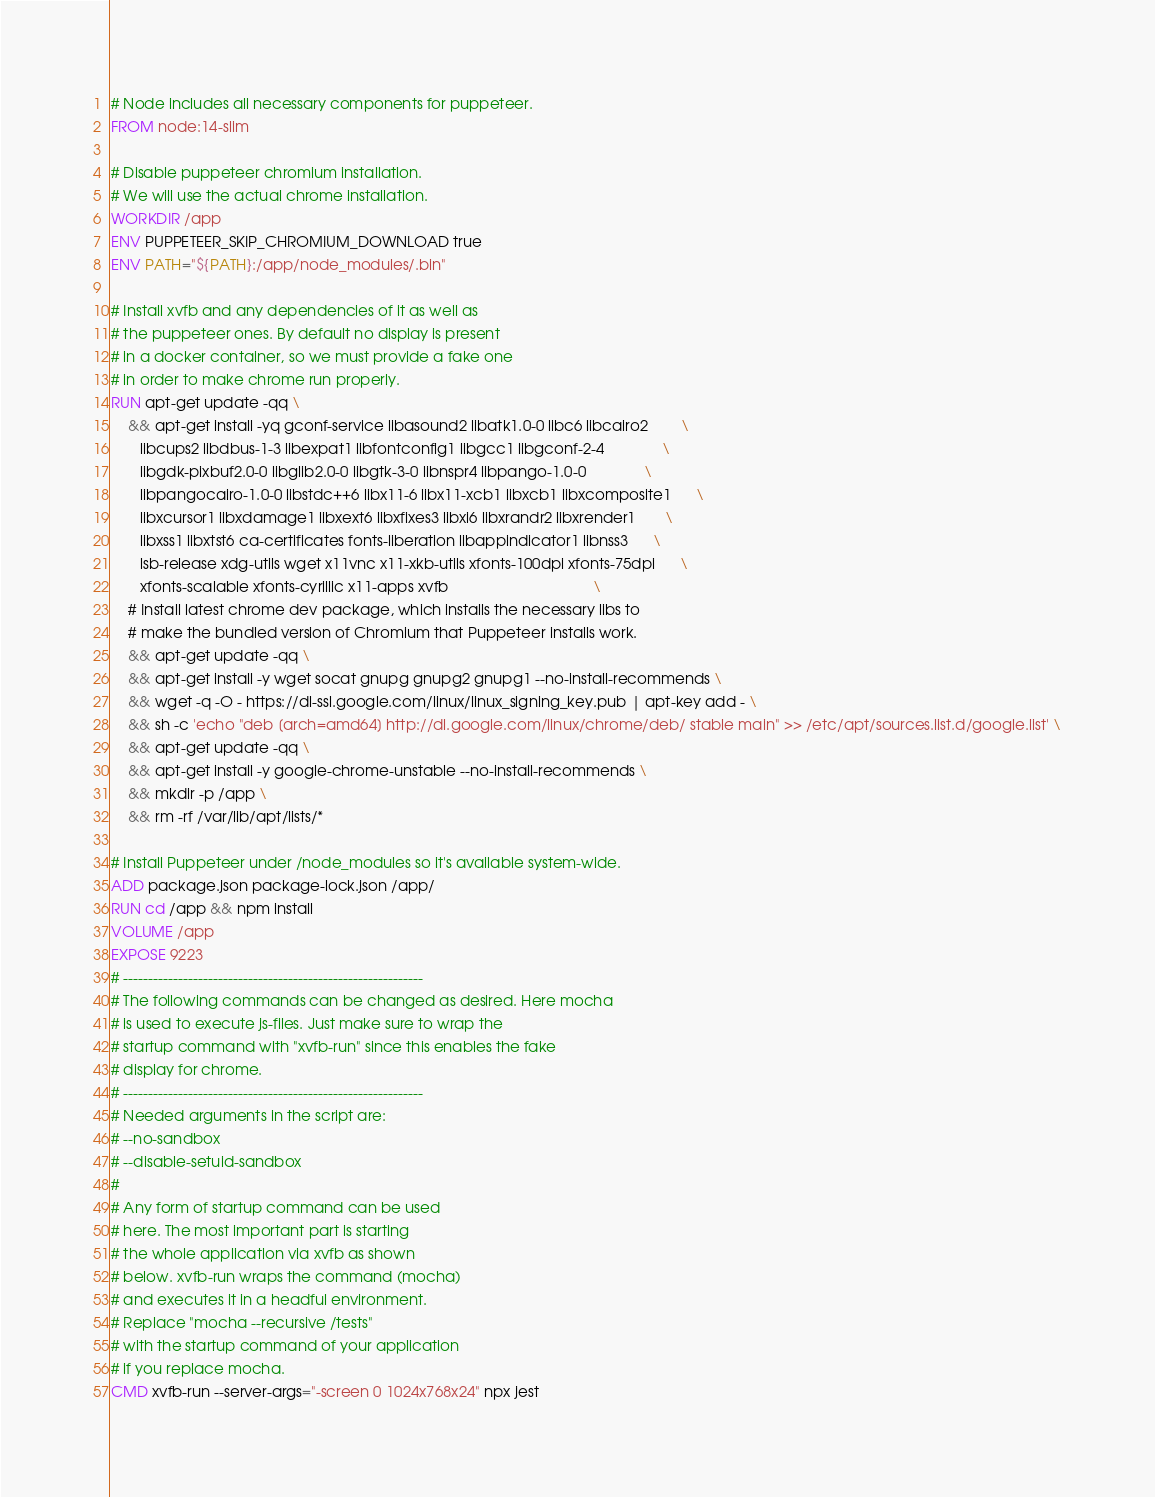Convert code to text. <code><loc_0><loc_0><loc_500><loc_500><_Dockerfile_># Node includes all necessary components for puppeteer.
FROM node:14-slim

# Disable puppeteer chromium installation.
# We will use the actual chrome installation.
WORKDIR /app
ENV PUPPETEER_SKIP_CHROMIUM_DOWNLOAD true
ENV PATH="${PATH}:/app/node_modules/.bin"

# Install xvfb and any dependencies of it as well as
# the puppeteer ones. By default no display is present
# in a docker container, so we must provide a fake one
# in order to make chrome run properly.
RUN apt-get update -qq \
    && apt-get install -yq gconf-service libasound2 libatk1.0-0 libc6 libcairo2        \
       libcups2 libdbus-1-3 libexpat1 libfontconfig1 libgcc1 libgconf-2-4              \
       libgdk-pixbuf2.0-0 libglib2.0-0 libgtk-3-0 libnspr4 libpango-1.0-0              \
       libpangocairo-1.0-0 libstdc++6 libx11-6 libx11-xcb1 libxcb1 libxcomposite1      \
       libxcursor1 libxdamage1 libxext6 libxfixes3 libxi6 libxrandr2 libxrender1       \
       libxss1 libxtst6 ca-certificates fonts-liberation libappindicator1 libnss3      \
       lsb-release xdg-utils wget x11vnc x11-xkb-utils xfonts-100dpi xfonts-75dpi      \
       xfonts-scalable xfonts-cyrillic x11-apps xvfb                                   \
    # Install latest chrome dev package, which installs the necessary libs to
    # make the bundled version of Chromium that Puppeteer installs work.
    && apt-get update -qq \
    && apt-get install -y wget socat gnupg gnupg2 gnupg1 --no-install-recommends \
    && wget -q -O - https://dl-ssl.google.com/linux/linux_signing_key.pub | apt-key add - \
    && sh -c 'echo "deb [arch=amd64] http://dl.google.com/linux/chrome/deb/ stable main" >> /etc/apt/sources.list.d/google.list' \
    && apt-get update -qq \
    && apt-get install -y google-chrome-unstable --no-install-recommends \
    && mkdir -p /app \
    && rm -rf /var/lib/apt/lists/*

# Install Puppeteer under /node_modules so it's available system-wide.
ADD package.json package-lock.json /app/
RUN cd /app && npm install
VOLUME /app
EXPOSE 9223
# ------------------------------------------------------------
# The following commands can be changed as desired. Here mocha
# is used to execute js-files. Just make sure to wrap the
# startup command with "xvfb-run" since this enables the fake
# display for chrome.
# ------------------------------------------------------------
# Needed arguments in the script are:
# --no-sandbox
# --disable-setuid-sandbox
#
# Any form of startup command can be used
# here. The most important part is starting
# the whole application via xvfb as shown
# below. xvfb-run wraps the command (mocha)
# and executes it in a headful environment.
# Replace "mocha --recursive /tests"
# with the startup command of your application
# if you replace mocha.
CMD xvfb-run --server-args="-screen 0 1024x768x24" npx jest
</code> 